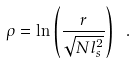Convert formula to latex. <formula><loc_0><loc_0><loc_500><loc_500>\rho = \ln \left ( \frac { r } { \sqrt { N l _ { s } ^ { 2 } } } \right ) \ .</formula> 